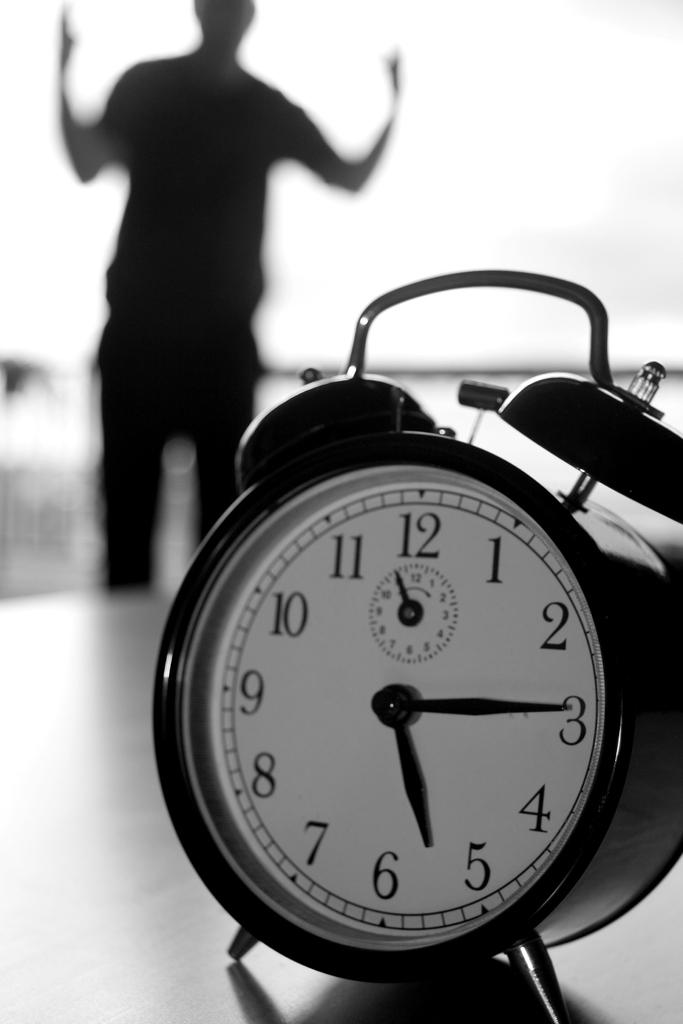<image>
Describe the image concisely. An alram clock showing the time is 5:15 with a man standing in the background. 